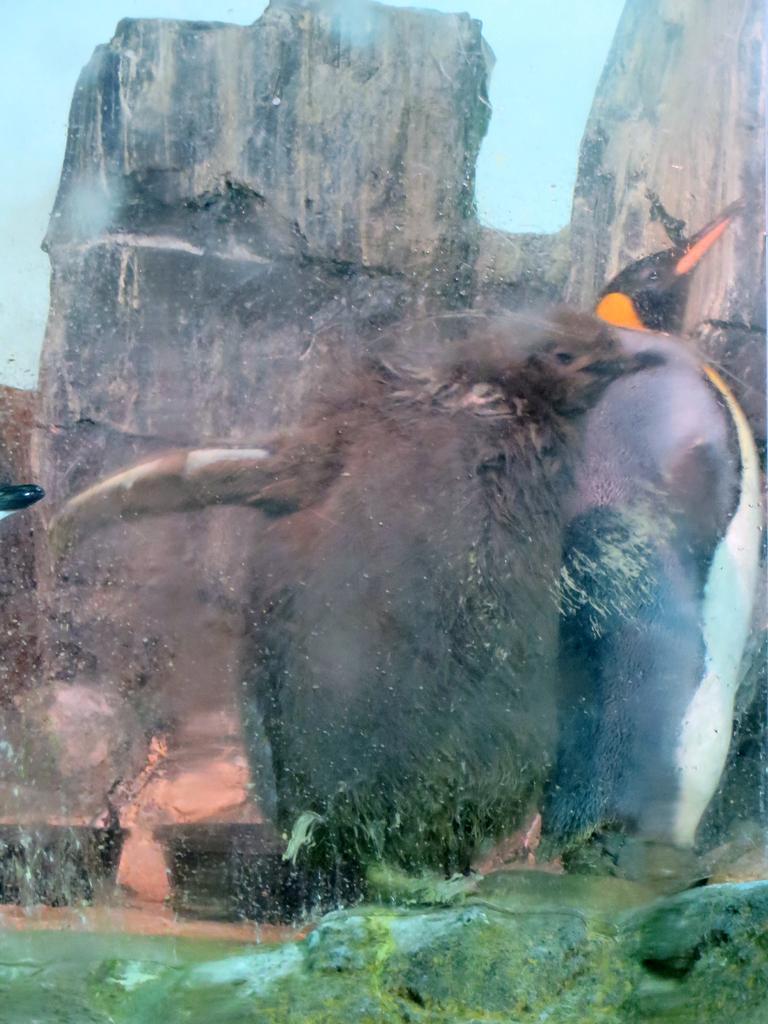Could you give a brief overview of what you see in this image? There is a bird in the middle of this image, and there are some rocks at the bottom of this image, and there is a mountain in the background. 